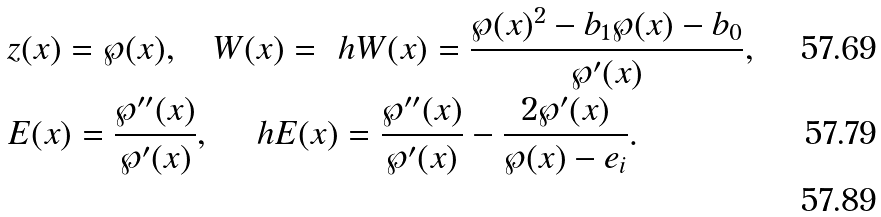<formula> <loc_0><loc_0><loc_500><loc_500>& z ( x ) = \wp ( x ) , \quad W ( x ) = \ h W ( x ) = \frac { \wp ( x ) ^ { 2 } - b _ { 1 } \wp ( x ) - b _ { 0 } } { \wp ^ { \prime } ( x ) } , \\ & E ( x ) = \frac { \wp ^ { \prime \prime } ( x ) } { \wp ^ { \prime } ( x ) } , \quad \ h E ( x ) = \frac { \wp ^ { \prime \prime } ( x ) } { \wp ^ { \prime } ( x ) } - \frac { 2 \wp ^ { \prime } ( x ) } { \wp ( x ) - e _ { i } } . \\</formula> 